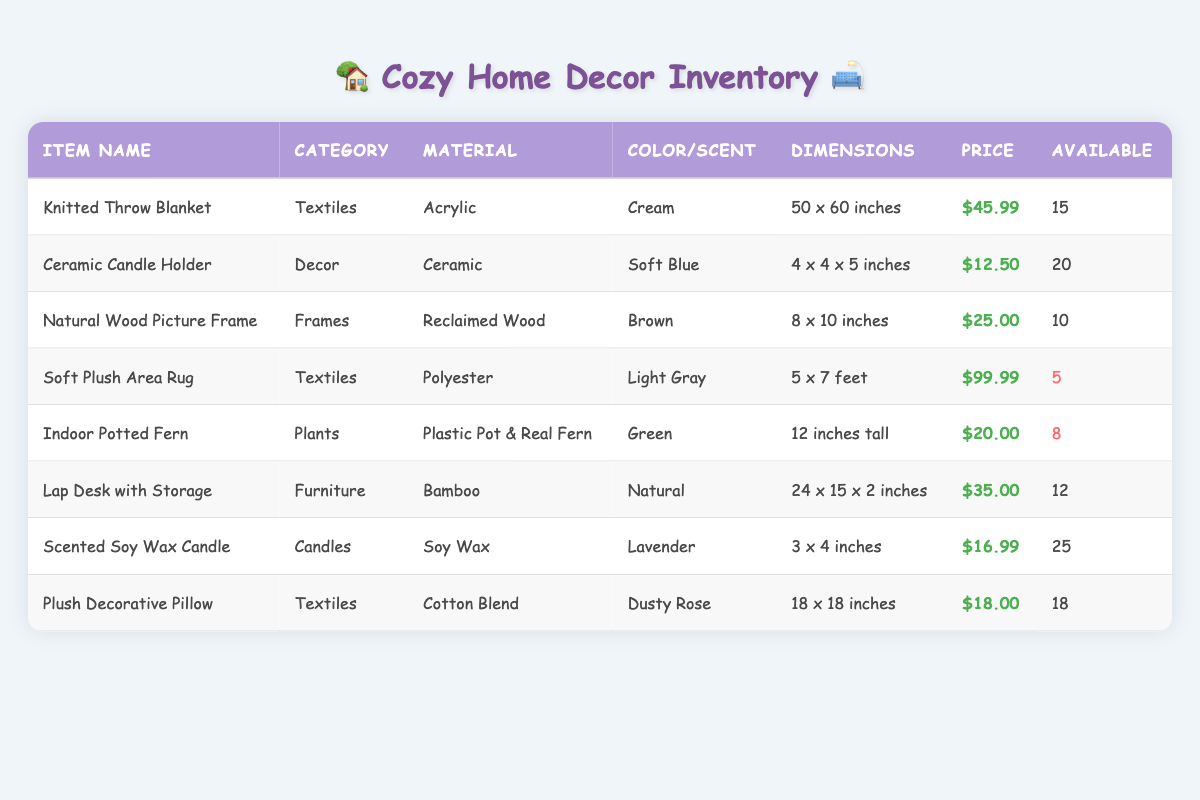What is the price of the Soft Plush Area Rug? The table lists the price for the Soft Plush Area Rug as $99.99, which is found in the "Price" column of the corresponding row for this item.
Answer: $99.99 How many Knitted Throw Blankets are available? The quantity available for the Knitted Throw Blanket is 15, as stated in the "Available" column of its row.
Answer: 15 Which item has the lowest available quantity? The Soft Plush Area Rug has the lowest available quantity at 5, which can be determined by comparing the "Available" values across all items in the table.
Answer: Soft Plush Area Rug What is the total price for all available Scented Soy Wax Candles? The total price is calculated by multiplying the price of each candle ($16.99) by the available quantity (25), which gives $16.99 * 25 = $424.75.
Answer: $424.75 Is there an Indoor Potted Fern available in the inventory? Yes, the Indoor Potted Fern is present in the inventory, as indicated by its entry in the table.
Answer: Yes What is the total number of items in the Textiles category? There are three items in the Textiles category: Knitted Throw Blanket, Soft Plush Area Rug, and Plush Decorative Pillow. So the total is 3.
Answer: 3 What is the average price of all available items in the inventory? To calculate the average, sum all prices: $45.99 + $12.50 + $25.00 + $99.99 + $20.00 + $35.00 + $16.99 + $18.00 = $  404.47. Then divide by 8 (the total items): $404.47 / 8 = $50.56.
Answer: $50.56 Does the inventory include any item made from bamboo? Yes, the Lap Desk with Storage is made from bamboo, according to the material listed in the table.
Answer: Yes What color is the Ceramic Candle Holder? The color of the Ceramic Candle Holder is Soft Blue, as indicated in its corresponding row under the "Color/Scent" column.
Answer: Soft Blue 